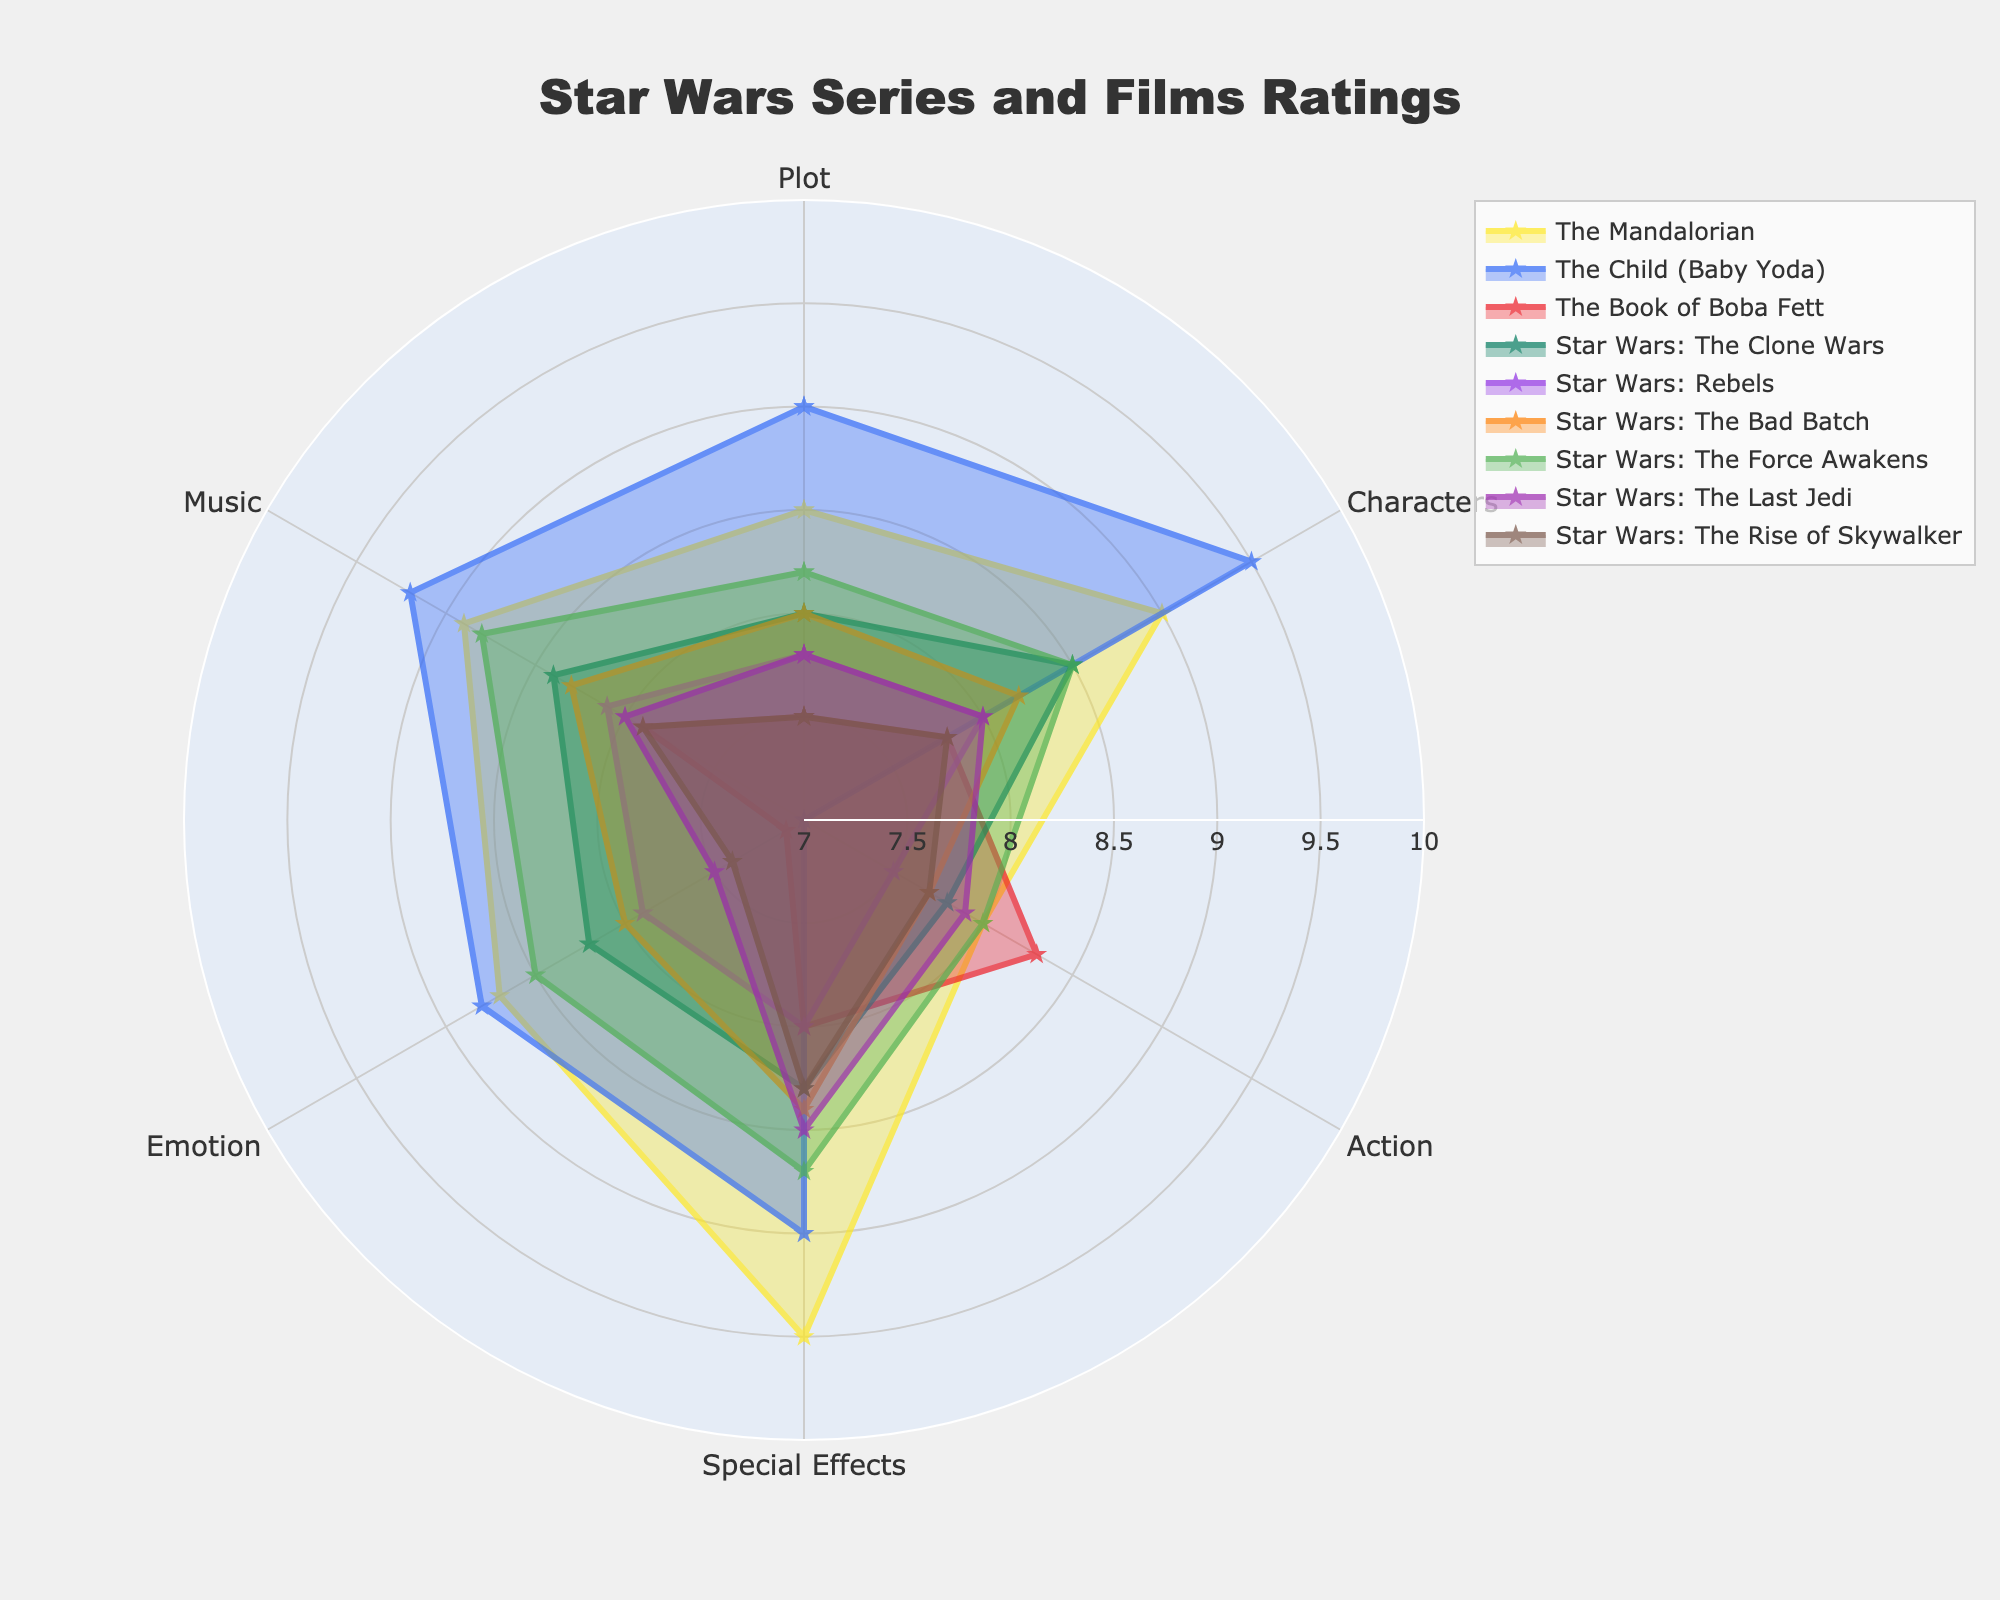What is the title of the radar chart? The title is usually found at the top of the radar chart. In this case, it clearly states "Star Wars Series and Films Ratings".
Answer: Star Wars Series and Films Ratings How many series/films are plotted on the radar chart? Count the distinct names in the legend or labels around the chart. There are 9 series/films mentioned in the data section, and all are represented in the figure.
Answer: 9 Which series/film has the highest rating for Special Effects? Look for the series with the highest value on the Special Effects axis. "The Mandalorian" has the highest value at 9.5.
Answer: The Mandalorian What is the average rating of "Star Wars: The Clone Wars" across all categories? Sum the values of each category for "Star Wars: The Clone Wars" and divide by the number of categories (6). (8.0 + 8.5 + 7.8 + 8.3 + 8.2 + 8.4) / 6 = 49.2 / 6 = 8.2
Answer: 8.2 Which series/film has the lowest ranking for Emotion? Find the minimum rating in the Emotion category from the data. "The Book of Boba Fett" has the lowest value at 7.1.
Answer: The Book of Boba Fett In which category is "The Mandalorian" rated higher than "The Force Awakens"? Compare the ratings for both series in each category and find where "The Mandalorian" has a higher value. "The Mandalorian" is higher in Special Effects (9.5 vs. 8.7) and Emotion (8.7 vs. 8.5).
Answer: Special Effects, Emotion How does the rating for Music of "The Child (Baby Yoda)" compare to "Star Wars: Rebels"? Look at the Music category for both entries. "The Child (Baby Yoda)" has 9.2, while "Star Wars: Rebels" has 8.1.
Answer: Higher What is the overall trend for the series/film with the highest rating in Characters? Identify the series/film with the highest Characters rating ("The Child (Baby Yoda)" at 9.5) and observe its ratings across other categories. "The Child (Baby Yoda)" generally has high ratings across all categories but is slightly lower in Action (7.0).
Answer: Generally high, lower in Action Which two series/films have the most similar rating pattern across all categories? Visual inspection or checking the values to see which ones follow a similar shape or have close ratings. "The Mandalorian" and "The Force Awakens" have very similar ratings in all categories.
Answer: The Mandalorian and The Force Awakens 